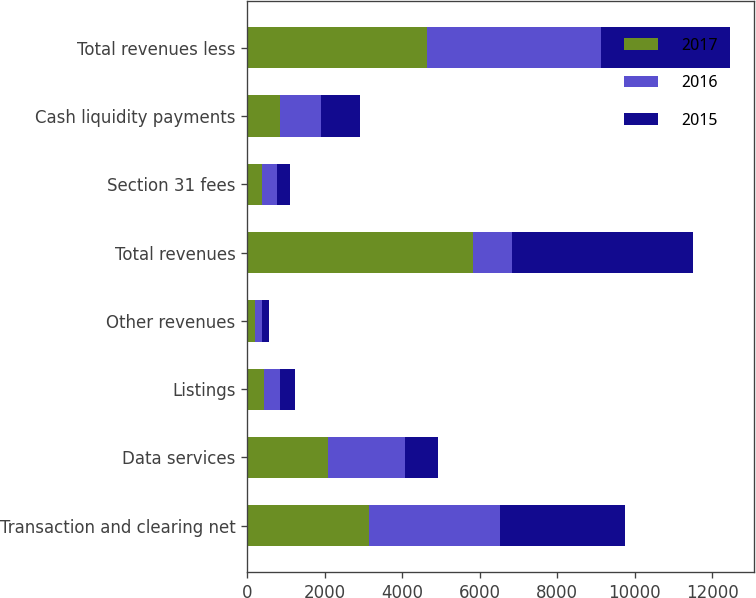Convert chart. <chart><loc_0><loc_0><loc_500><loc_500><stacked_bar_chart><ecel><fcel>Transaction and clearing net<fcel>Data services<fcel>Listings<fcel>Other revenues<fcel>Total revenues<fcel>Section 31 fees<fcel>Cash liquidity payments<fcel>Total revenues less<nl><fcel>2017<fcel>3131<fcel>2084<fcel>417<fcel>202<fcel>5834<fcel>372<fcel>833<fcel>4629<nl><fcel>2016<fcel>3384<fcel>1978<fcel>419<fcel>177<fcel>995<fcel>389<fcel>1070<fcel>4499<nl><fcel>2015<fcel>3228<fcel>871<fcel>405<fcel>178<fcel>4682<fcel>349<fcel>995<fcel>3338<nl></chart> 